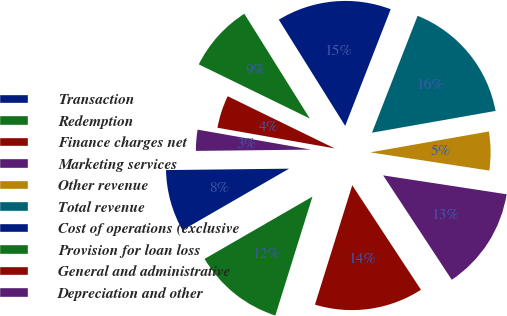Convert chart. <chart><loc_0><loc_0><loc_500><loc_500><pie_chart><fcel>Transaction<fcel>Redemption<fcel>Finance charges net<fcel>Marketing services<fcel>Other revenue<fcel>Total revenue<fcel>Cost of operations (exclusive<fcel>Provision for loan loss<fcel>General and administrative<fcel>Depreciation and other<nl><fcel>8.15%<fcel>11.85%<fcel>14.07%<fcel>13.33%<fcel>5.19%<fcel>16.3%<fcel>14.81%<fcel>8.89%<fcel>4.44%<fcel>2.96%<nl></chart> 